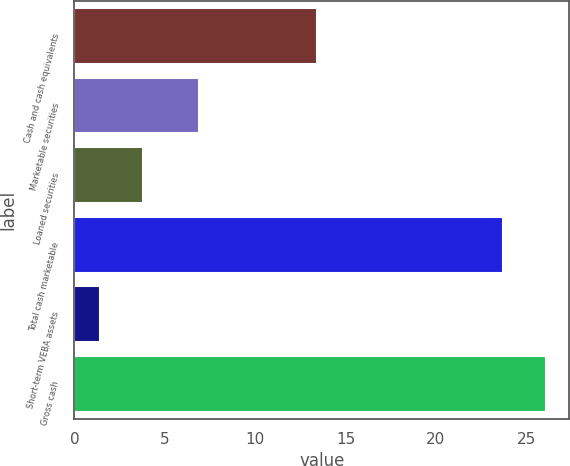Convert chart. <chart><loc_0><loc_0><loc_500><loc_500><bar_chart><fcel>Cash and cash equivalents<fcel>Marketable securities<fcel>Loaned securities<fcel>Total cash marketable<fcel>Short-term VEBA assets<fcel>Gross cash<nl><fcel>13.4<fcel>6.9<fcel>3.77<fcel>23.7<fcel>1.4<fcel>26.07<nl></chart> 